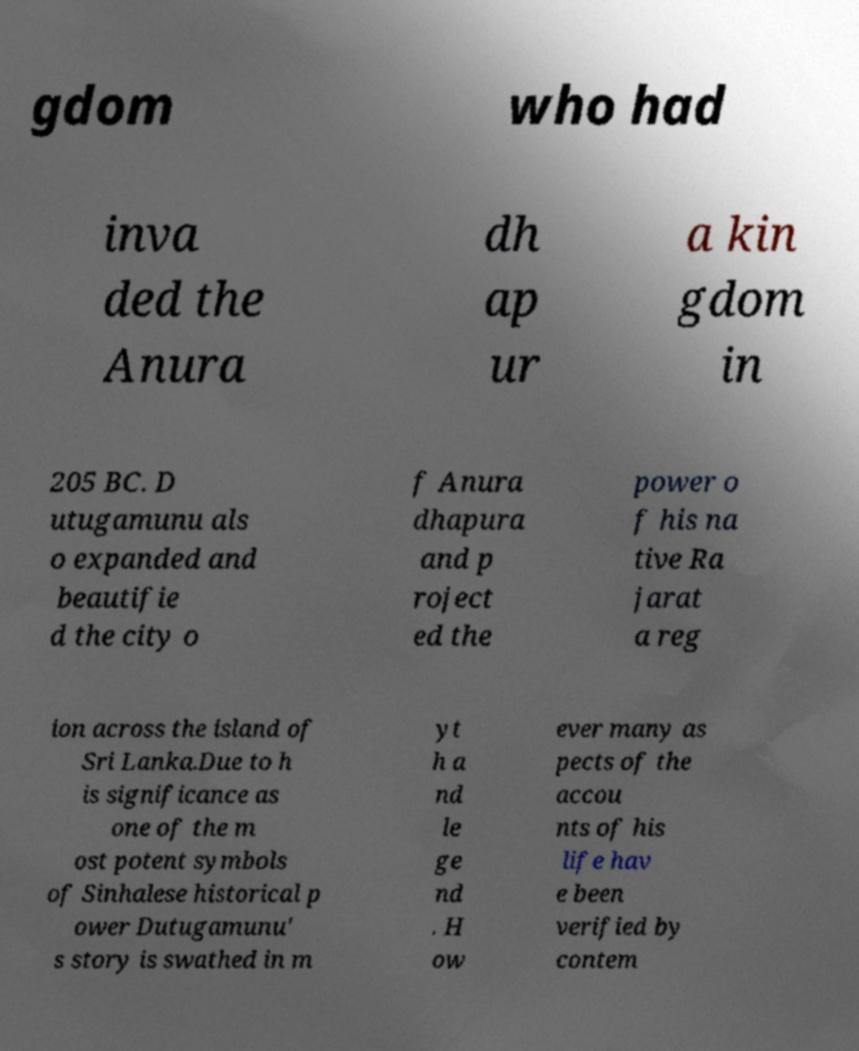Could you assist in decoding the text presented in this image and type it out clearly? gdom who had inva ded the Anura dh ap ur a kin gdom in 205 BC. D utugamunu als o expanded and beautifie d the city o f Anura dhapura and p roject ed the power o f his na tive Ra jarat a reg ion across the island of Sri Lanka.Due to h is significance as one of the m ost potent symbols of Sinhalese historical p ower Dutugamunu' s story is swathed in m yt h a nd le ge nd . H ow ever many as pects of the accou nts of his life hav e been verified by contem 